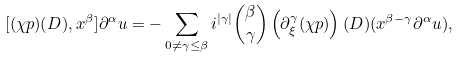Convert formula to latex. <formula><loc_0><loc_0><loc_500><loc_500>[ ( \chi p ) ( D ) , x ^ { \beta } ] \partial ^ { \alpha } u = - \sum _ { 0 \not = \gamma \leq \beta } i ^ { | \gamma | } \binom { \beta } { \gamma } \left ( \partial ^ { \gamma } _ { \xi } ( \chi p ) \right ) ( D ) ( x ^ { \beta - \gamma } \partial ^ { \alpha } u ) ,</formula> 